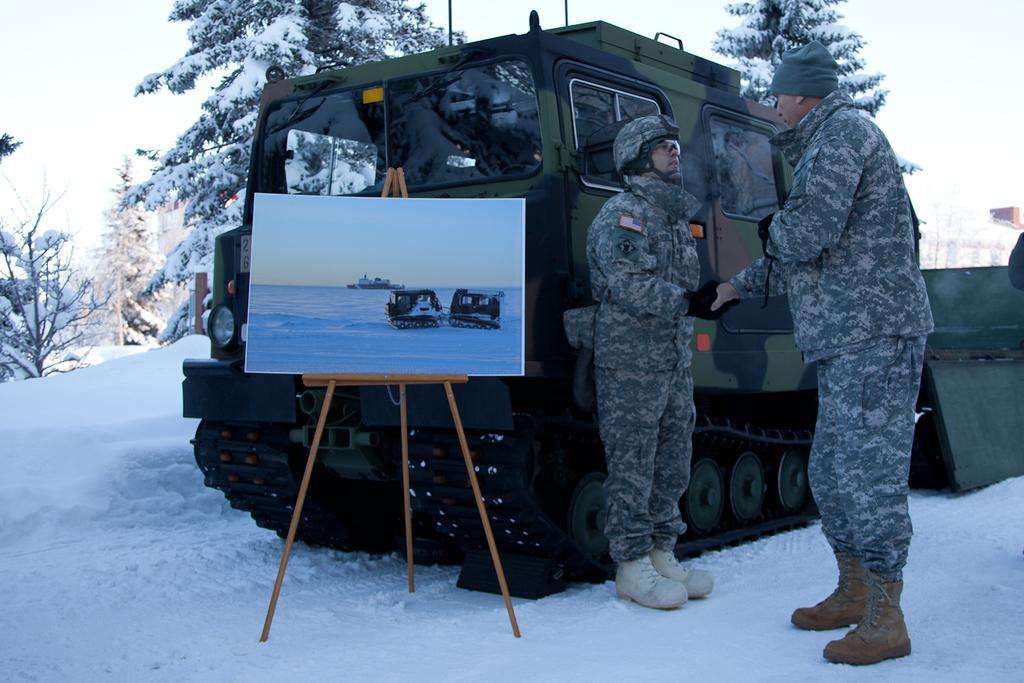Describe this image in one or two sentences. There are two people standing and shaking hands each other and this man wore helmet and glasses. We can see board with stand and vehicle on snow. In the background we can see trees and sky. 